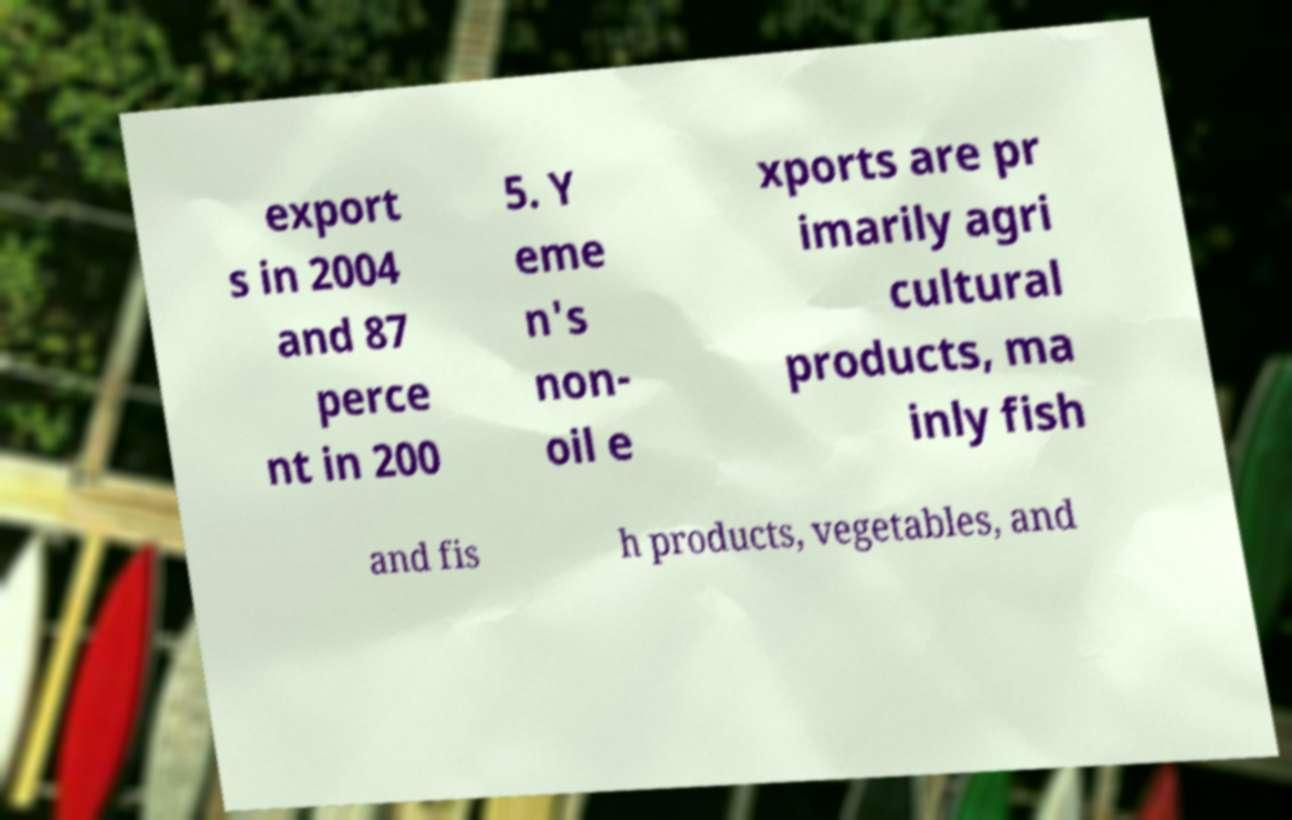Can you read and provide the text displayed in the image?This photo seems to have some interesting text. Can you extract and type it out for me? export s in 2004 and 87 perce nt in 200 5. Y eme n's non- oil e xports are pr imarily agri cultural products, ma inly fish and fis h products, vegetables, and 